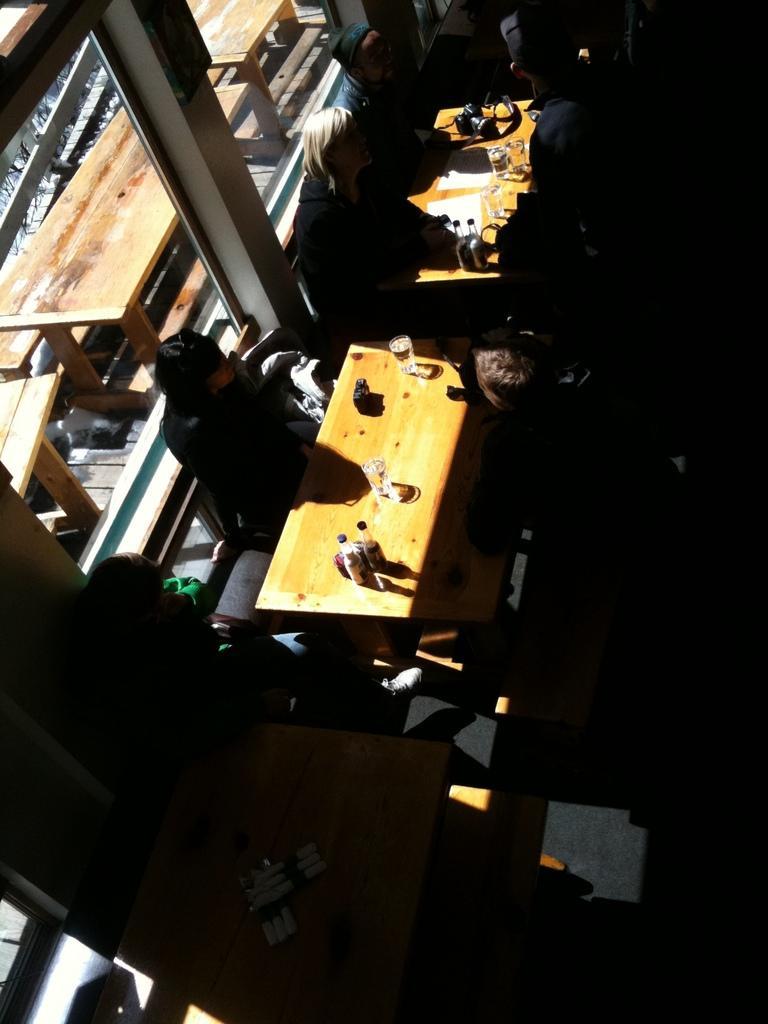Describe this image in one or two sentences. In this image I can see some people. I can see some objects on the table. On the left side I can see some tables behind the window. 